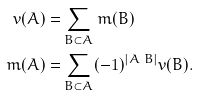<formula> <loc_0><loc_0><loc_500><loc_500>v ( A ) = & \sum _ { B \subset A } m ( B ) \\ m ( A ) = & \sum _ { B \subset A } ( - 1 ) ^ { | A \ B | } v ( B ) .</formula> 